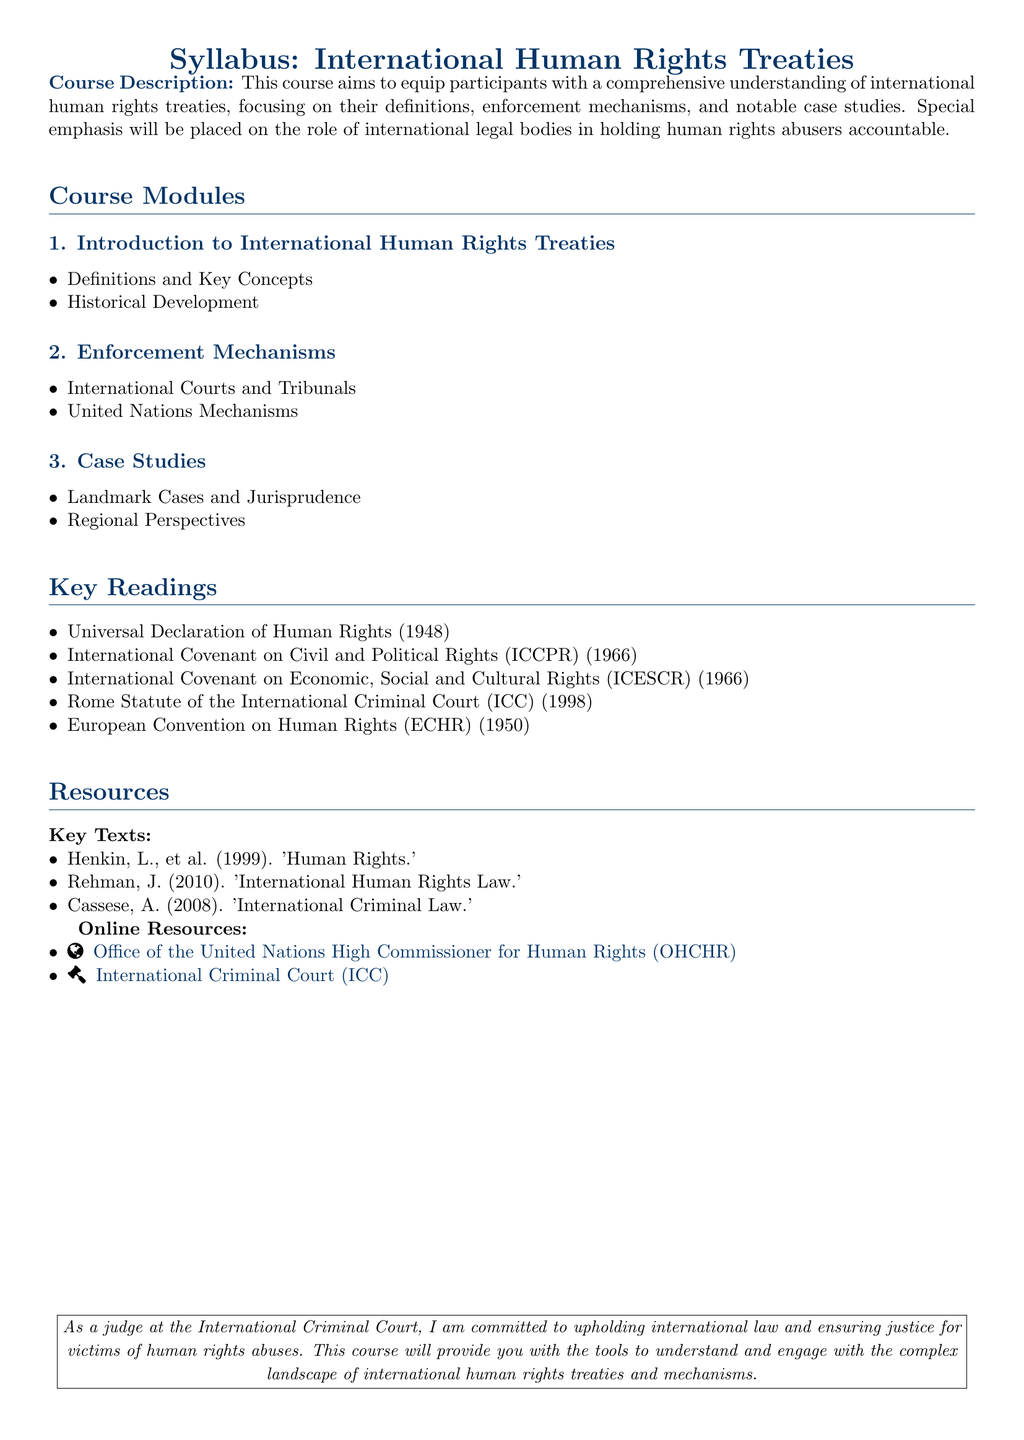What is the course title? The course title is explicitly mentioned at the top of the syllabus as "International Human Rights Treaties."
Answer: International Human Rights Treaties What year was the Universal Declaration of Human Rights adopted? The year of adoption of the Universal Declaration of Human Rights is stated in the key readings section.
Answer: 1948 Name one enforcement mechanism discussed in the syllabus. The syllabus lists "International Courts and Tribunals" under the enforcement mechanisms section.
Answer: International Courts and Tribunals Which document is known as the Rome Statute? The syllabus refers to the Rome Statute in the key readings section, identifying it by its audience and significance.
Answer: Rome Statute of the International Criminal Court How many case studies are outlined in the syllabus? The syllabus explicitly states there are two items under the case studies section, indicating multiple studies will be considered.
Answer: 2 Identify a key text mentioned in the resources section. The resources section specifically names "Human Rights" by Henkin, et al. as a key text.
Answer: Human Rights What is the main focus of the course? The syllabus summarizes the course's main focus regarding international human rights treaties and their enforcement mechanisms.
Answer: International human rights treaties Who is committed to upholding international law? The syllabus includes a statement by the judge, indicating a personal commitment to justice for victims.
Answer: The judge at the International Criminal Court 